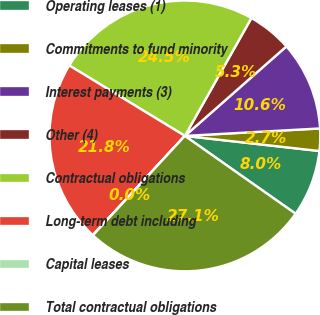<chart> <loc_0><loc_0><loc_500><loc_500><pie_chart><fcel>Operating leases (1)<fcel>Commitments to fund minority<fcel>Interest payments (3)<fcel>Other (4)<fcel>Contractual obligations<fcel>Long-term debt including<fcel>Capital leases<fcel>Total contractual obligations<nl><fcel>7.97%<fcel>2.66%<fcel>10.62%<fcel>5.32%<fcel>24.47%<fcel>21.82%<fcel>0.01%<fcel>27.13%<nl></chart> 